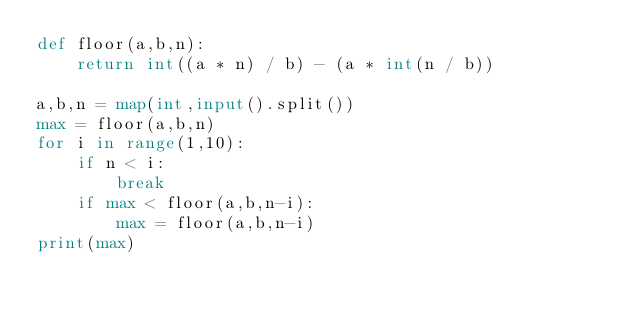Convert code to text. <code><loc_0><loc_0><loc_500><loc_500><_Python_>def floor(a,b,n):
    return int((a * n) / b) - (a * int(n / b))

a,b,n = map(int,input().split())
max = floor(a,b,n)
for i in range(1,10):
    if n < i:
        break
    if max < floor(a,b,n-i):
        max = floor(a,b,n-i)
print(max)
    </code> 